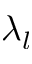Convert formula to latex. <formula><loc_0><loc_0><loc_500><loc_500>\lambda _ { l }</formula> 